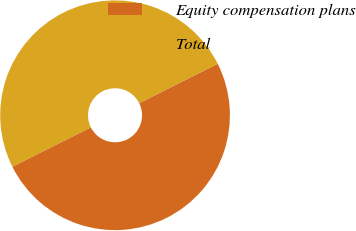Convert chart to OTSL. <chart><loc_0><loc_0><loc_500><loc_500><pie_chart><fcel>Equity compensation plans<fcel>Total<nl><fcel>50.0%<fcel>50.0%<nl></chart> 